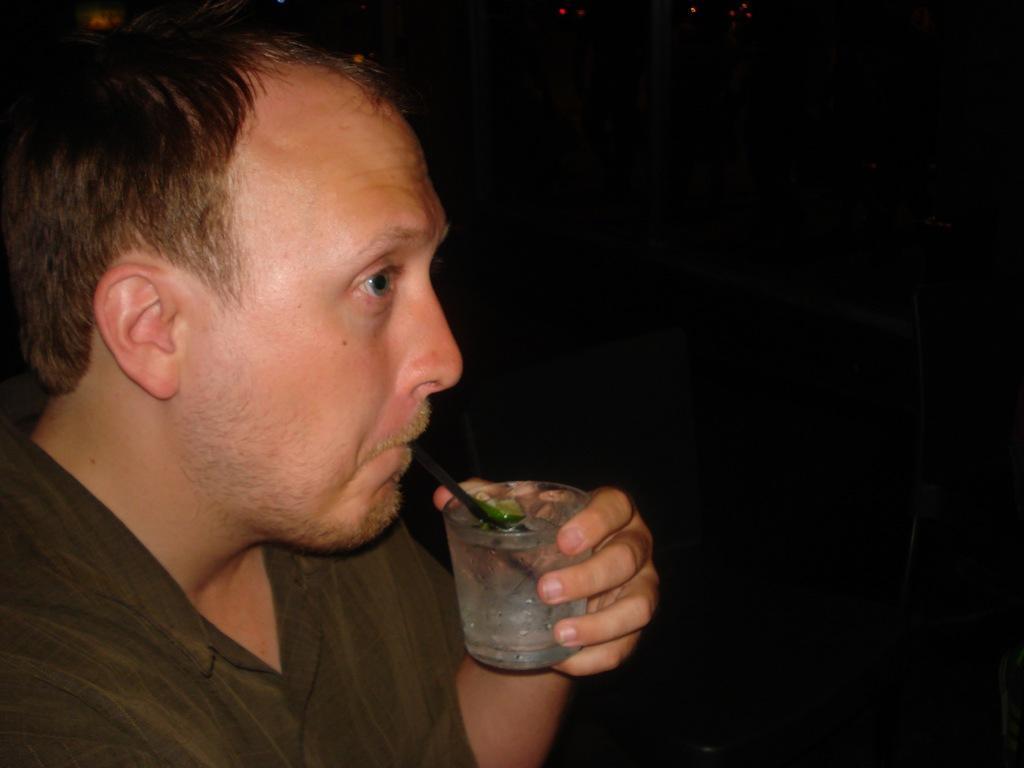Describe this image in one or two sentences. In this picture we can see a man is holding a glass of drink, there is a dark background. 